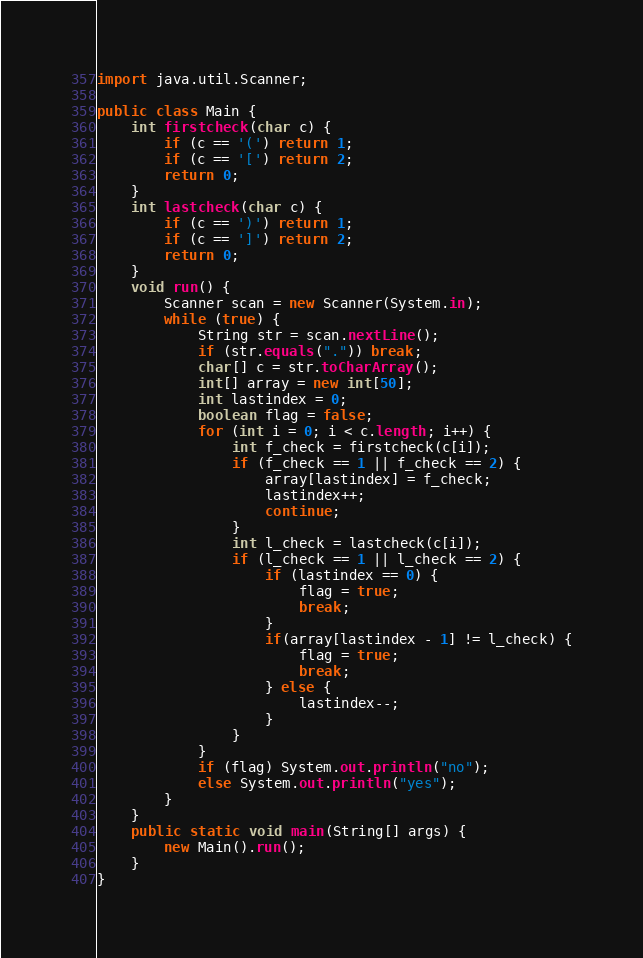<code> <loc_0><loc_0><loc_500><loc_500><_Java_>import java.util.Scanner;

public class Main {
	int firstcheck(char c) {
		if (c == '(') return 1;
		if (c == '[') return 2;
		return 0;
	}
	int lastcheck(char c) {
		if (c == ')') return 1;
		if (c == ']') return 2;
		return 0;
	}
	void run() {
		Scanner scan = new Scanner(System.in);
		while (true) {
			String str = scan.nextLine();
			if (str.equals(".")) break;
			char[] c = str.toCharArray();
			int[] array = new int[50];
			int lastindex = 0;
			boolean flag = false;
			for (int i = 0; i < c.length; i++) {
				int f_check = firstcheck(c[i]);
				if (f_check == 1 || f_check == 2) {
					array[lastindex] = f_check;
					lastindex++;
					continue;
				}
				int l_check = lastcheck(c[i]);
				if (l_check == 1 || l_check == 2) {
					if (lastindex == 0) {
						flag = true;
						break;
					}
					if(array[lastindex - 1] != l_check) {
						flag = true;
						break;
					} else {
						lastindex--;
					}
				}
			}
			if (flag) System.out.println("no");
			else System.out.println("yes");
		}
	}
	public static void main(String[] args) {
		new Main().run();
	}
}</code> 